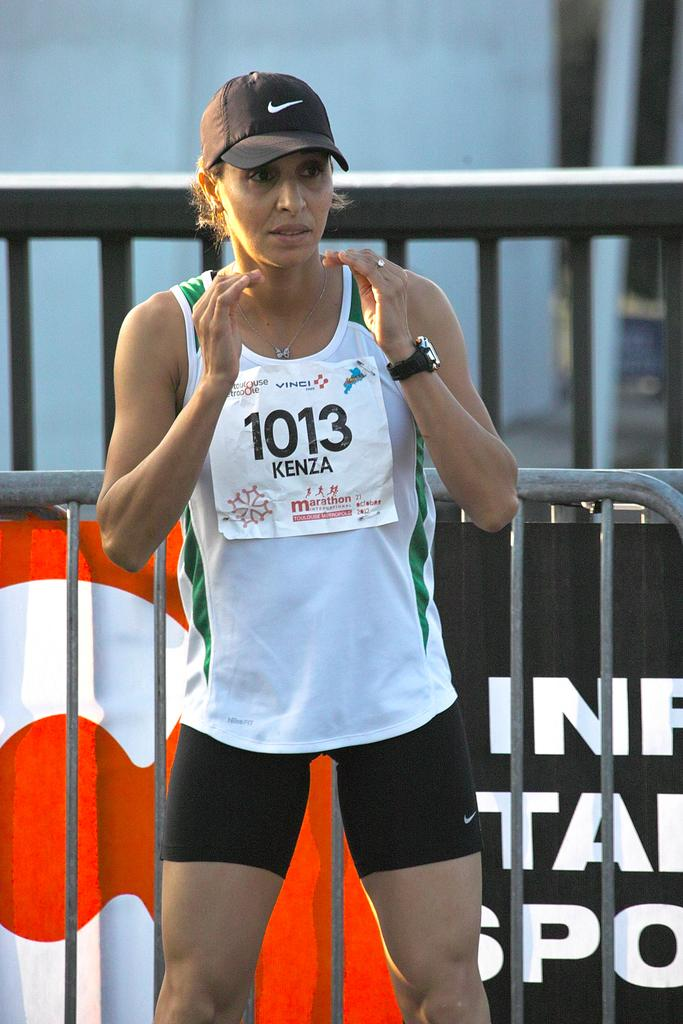Provide a one-sentence caption for the provided image. Runner #1013 Kenza of marathon International waits on the sidelines. 